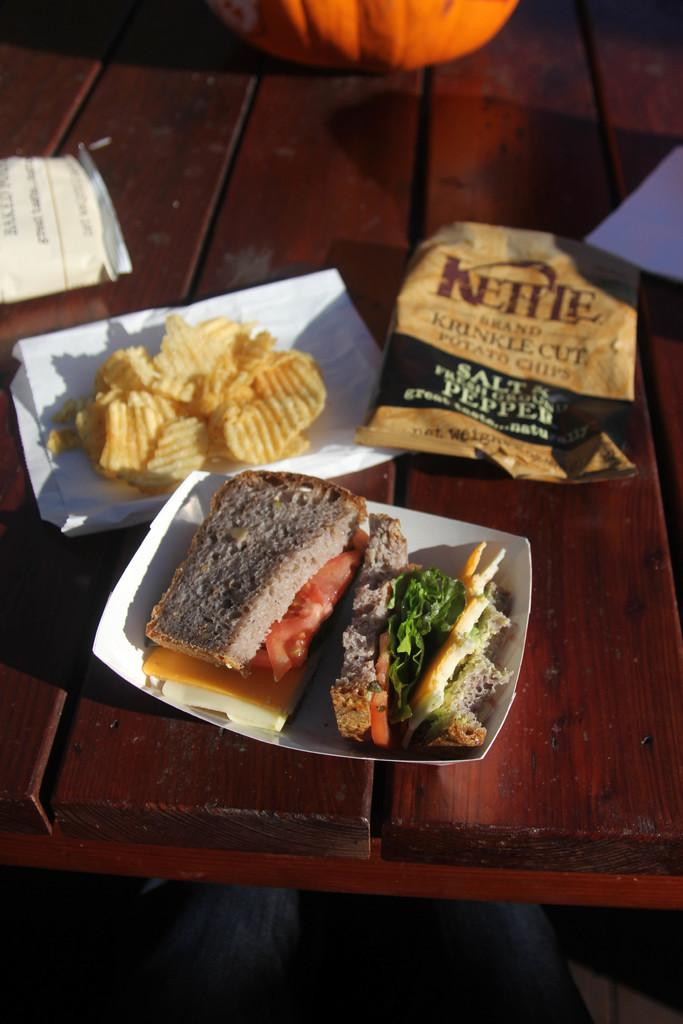What type of food is visible in the image? There is a sandwich in the image. Where is the sandwich located? The sandwich is on a plate in the image. What other food item can be seen in the image? There are chips on the left side of the image. What is the packaging for the chips? There is a wrapper in the image. On what surface are the sandwich, chips, and wrapper placed? They are placed on a table in the image. Can you tell me what the girl is answering at the party in the image? There is no girl or party present in the image; it only features a sandwich, chips, and a wrapper on a table. 